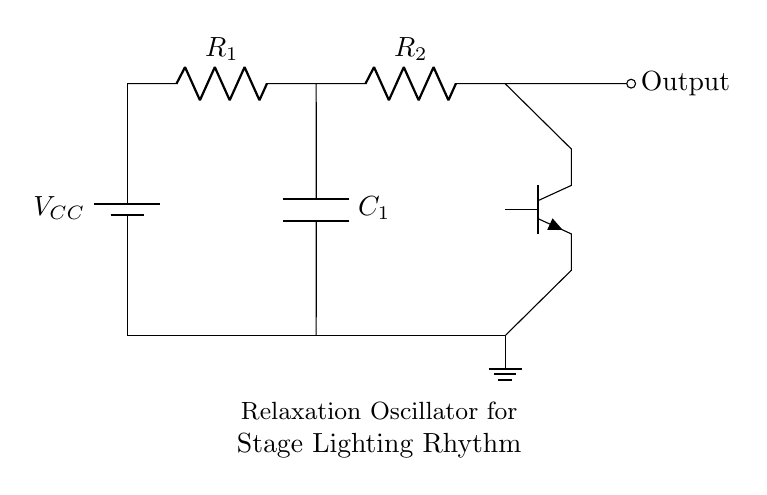What type of oscillator is represented in the circuit? The circuit is a relaxation oscillator, which is designed to generate periodic signals. The diagram specifies this in the labels and the configuration of the components.
Answer: Relaxation oscillator What component generates the output signals? The output signals are generated by the transistor, which is the active component in the circuit responsible for amplifying and switching the signals. The circuit diagram clearly shows the transistor's position and connections.
Answer: Transistor What components are connected in series with the power supply? The power supply is connected in series with two resistors, R1 and R2, allowing for the control of the voltage and current in the circuit. The diagram indicates these connections clearly.
Answer: R1 and R2 What is the role of the capacitor in this circuit? The capacitor in this circuit serves to store charge and influence the timing characteristics of the oscillator, determining the periodicity of the output signal. The diagram shows the capacitor's connections related to the timing function.
Answer: Timing characteristic How does the output signal relate to the power supply voltage? The output signal is influenced by the power supply voltage, which provides the necessary energy for the circuit. According to the design, the output signal's amplitude is typically related to the supply voltage because it powers the active components.
Answer: Related to VCC Which two resistances are likely determining the frequency of oscillation? The two resistors R1 and R2 are likely determining the frequency of oscillation due to their roles in controlling the charge and discharge times of the associated capacitor. The relationship between these components affects the oscillation period.
Answer: R1 and R2 